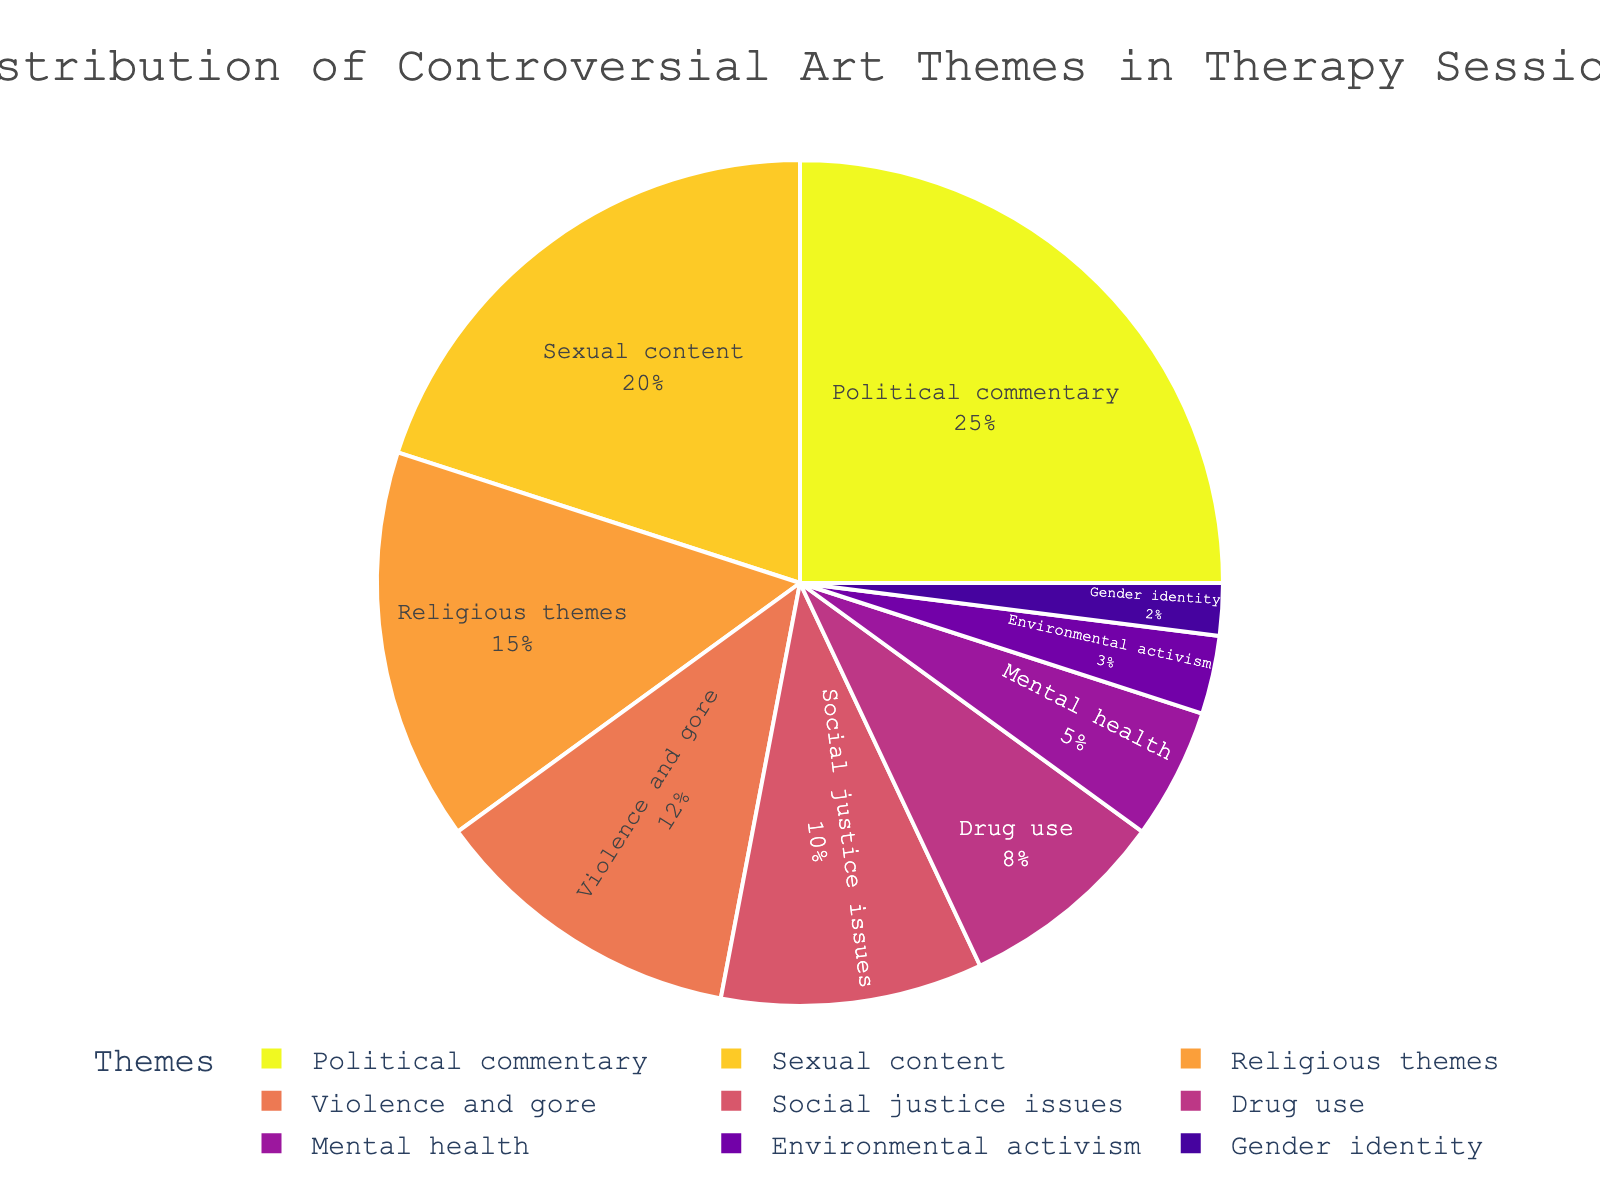what is the most common theme addressed in therapy sessions? The largest portion of the pie chart represents the most common theme, which is labeled at 25% of the overall distribution. This segment is associated with "Political commentary."
Answer: Political commentary Which two themes combined make up more than 40% of the distribution? To find two themes that together make up more than 40%, look for contiguous or large segments in the chart. Combining "Political commentary" (25%) and "Sexual content" (20%) results in 25% + 20% = 45%.
Answer: Political commentary and Sexual content How much more prevalent is the theme "Political commentary" compared to "Drug use"? To compare the prevalence, look at their respective percentages. "Political commentary" is 25% and "Drug use" is 8%. The difference is 25% - 8% = 17%.
Answer: 17% Which theme is the least addressed in therapy sessions? The smallest segment in the pie chart represents the theme that is least addressed. This segment is labeled with 2% and associated with "Gender identity."
Answer: Gender identity What is the total percentage of themes related to social issues, including “Political commentary” and “Social justice issues”? Add the percentages of "Political commentary" (25%) and "Social justice issues" (10%). The total percentage is 25% + 10% = 35%.
Answer: 35% If themes "Violence and gore" and "Mental health" were combined, what percentage would they cover? To combine, add "Violence and gore" (12%) and "Mental health" (5%). The sum is 12% + 5% = 17%.
Answer: 17% By how much does the percentage of "Sexual content" exceed that of "Religious themes"? Compare their values: "Sexual content" is 20% and "Religious themes" is 15%. The excess amount is 20% - 15% = 5%.
Answer: 5% Which category is more prevalent, "Social justice issues" or "Drug use"? Look at the respective percentages: "Social justice issues" is 10% and "Drug use" is 8%. "Social justice issues" is more prevalent.
Answer: Social justice issues Is the theme "Environmental activism" more or less than half of "Sexual content"? Compare the percentages: "Sexual content" is 20% and half of that is 10%. "Environmental activism" is 3%, which is less than half.
Answer: Less than half What is the combined percentage of the three least addressed themes in therapy sessions? Sum the percentages of the three smallest segments: "Gender identity" (2%), "Environmental activism" (3%), and "Mental health" (5%). The combined percentage is 2% + 3% + 5% = 10%.
Answer: 10% 